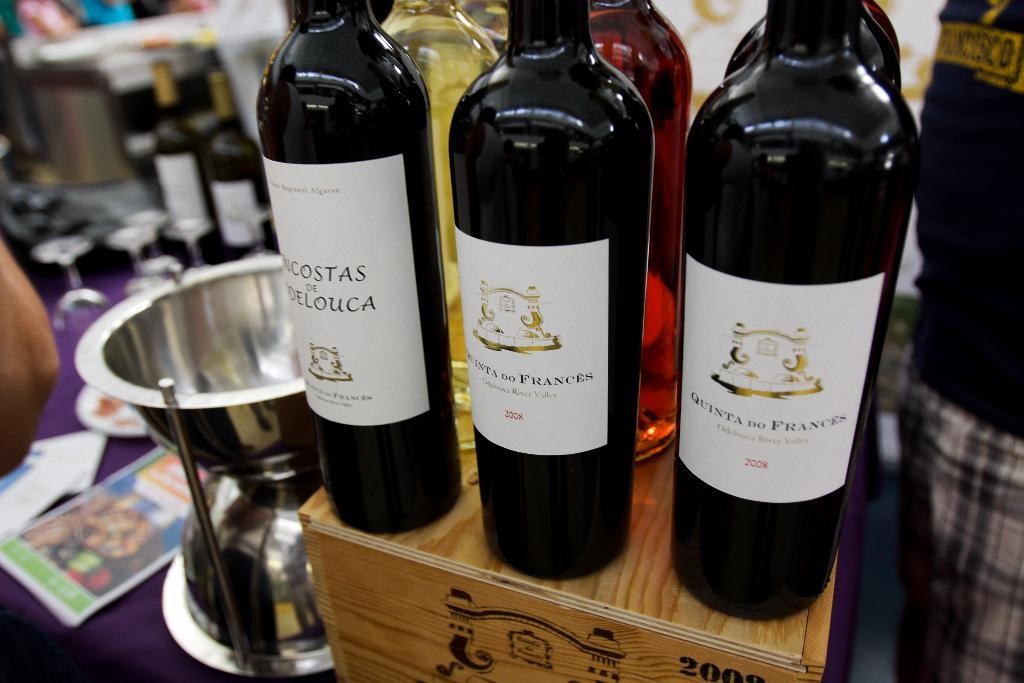Provide a one-sentence caption for the provided image. Two bottles of Quinta do Frances from 2008 sit on a crate with some other wine bottles. 